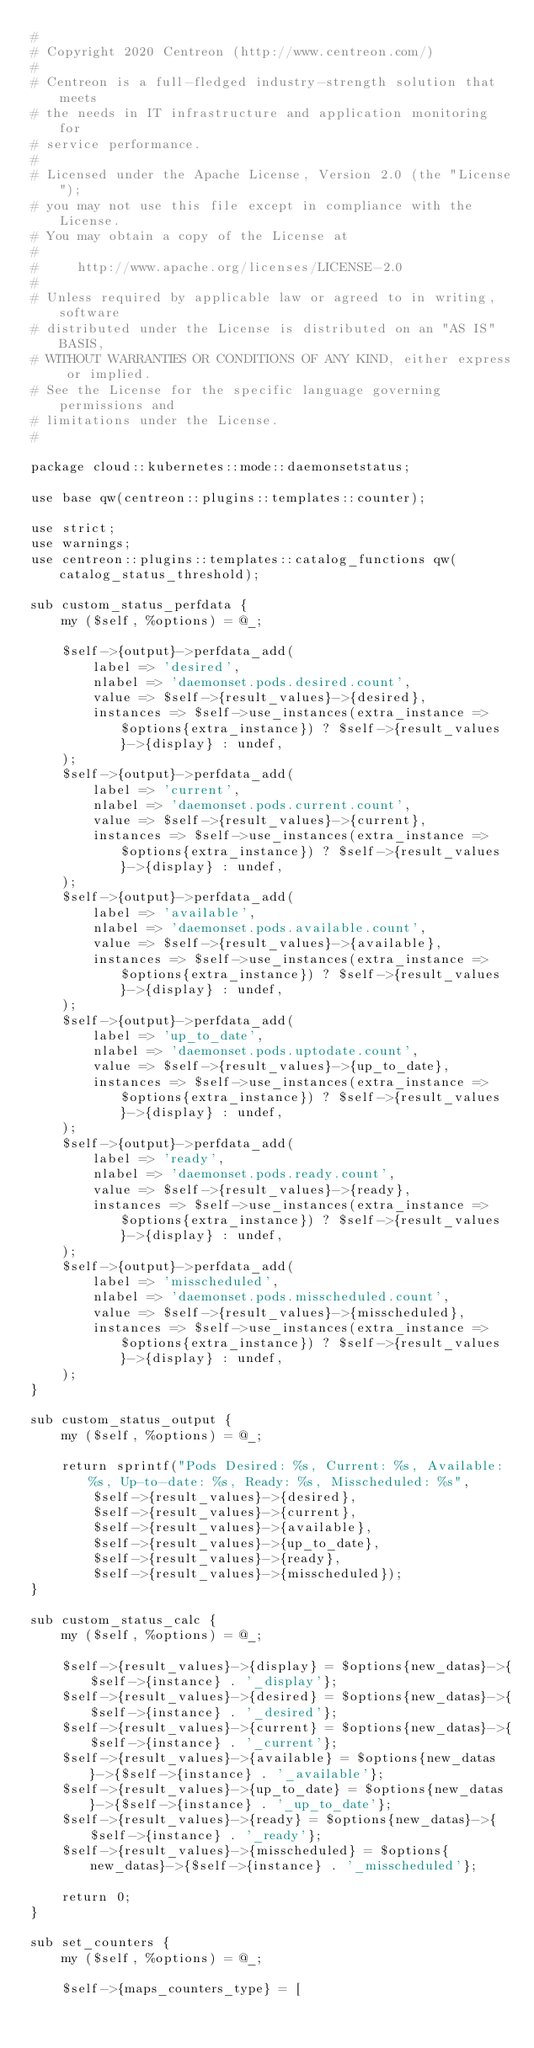<code> <loc_0><loc_0><loc_500><loc_500><_Perl_>#
# Copyright 2020 Centreon (http://www.centreon.com/)
#
# Centreon is a full-fledged industry-strength solution that meets
# the needs in IT infrastructure and application monitoring for
# service performance.
#
# Licensed under the Apache License, Version 2.0 (the "License");
# you may not use this file except in compliance with the License.
# You may obtain a copy of the License at
#
#     http://www.apache.org/licenses/LICENSE-2.0
#
# Unless required by applicable law or agreed to in writing, software
# distributed under the License is distributed on an "AS IS" BASIS,
# WITHOUT WARRANTIES OR CONDITIONS OF ANY KIND, either express or implied.
# See the License for the specific language governing permissions and
# limitations under the License.
#

package cloud::kubernetes::mode::daemonsetstatus;

use base qw(centreon::plugins::templates::counter);

use strict;
use warnings;
use centreon::plugins::templates::catalog_functions qw(catalog_status_threshold);

sub custom_status_perfdata {
    my ($self, %options) = @_;
    
    $self->{output}->perfdata_add(
        label => 'desired',
        nlabel => 'daemonset.pods.desired.count',
        value => $self->{result_values}->{desired},
        instances => $self->use_instances(extra_instance => $options{extra_instance}) ? $self->{result_values}->{display} : undef,
    );
    $self->{output}->perfdata_add(
        label => 'current',
        nlabel => 'daemonset.pods.current.count',
        value => $self->{result_values}->{current},
        instances => $self->use_instances(extra_instance => $options{extra_instance}) ? $self->{result_values}->{display} : undef,
    );
    $self->{output}->perfdata_add(
        label => 'available',
        nlabel => 'daemonset.pods.available.count',
        value => $self->{result_values}->{available},
        instances => $self->use_instances(extra_instance => $options{extra_instance}) ? $self->{result_values}->{display} : undef,
    );
    $self->{output}->perfdata_add(
        label => 'up_to_date',
        nlabel => 'daemonset.pods.uptodate.count',
        value => $self->{result_values}->{up_to_date},
        instances => $self->use_instances(extra_instance => $options{extra_instance}) ? $self->{result_values}->{display} : undef,
    );
    $self->{output}->perfdata_add(
        label => 'ready',
        nlabel => 'daemonset.pods.ready.count',
        value => $self->{result_values}->{ready},
        instances => $self->use_instances(extra_instance => $options{extra_instance}) ? $self->{result_values}->{display} : undef,
    );
    $self->{output}->perfdata_add(
        label => 'misscheduled',
        nlabel => 'daemonset.pods.misscheduled.count',
        value => $self->{result_values}->{misscheduled},
        instances => $self->use_instances(extra_instance => $options{extra_instance}) ? $self->{result_values}->{display} : undef,
    );
}

sub custom_status_output {
    my ($self, %options) = @_;

    return sprintf("Pods Desired: %s, Current: %s, Available: %s, Up-to-date: %s, Ready: %s, Misscheduled: %s",
        $self->{result_values}->{desired},
        $self->{result_values}->{current},
        $self->{result_values}->{available},
        $self->{result_values}->{up_to_date},
        $self->{result_values}->{ready},
        $self->{result_values}->{misscheduled});
}

sub custom_status_calc {
    my ($self, %options) = @_;

    $self->{result_values}->{display} = $options{new_datas}->{$self->{instance} . '_display'};
    $self->{result_values}->{desired} = $options{new_datas}->{$self->{instance} . '_desired'};
    $self->{result_values}->{current} = $options{new_datas}->{$self->{instance} . '_current'};
    $self->{result_values}->{available} = $options{new_datas}->{$self->{instance} . '_available'};
    $self->{result_values}->{up_to_date} = $options{new_datas}->{$self->{instance} . '_up_to_date'};
    $self->{result_values}->{ready} = $options{new_datas}->{$self->{instance} . '_ready'};
    $self->{result_values}->{misscheduled} = $options{new_datas}->{$self->{instance} . '_misscheduled'};

    return 0;
}

sub set_counters {
    my ($self, %options) = @_;
    
    $self->{maps_counters_type} = [</code> 